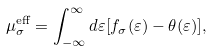<formula> <loc_0><loc_0><loc_500><loc_500>\mu ^ { \text {eff} } _ { \sigma } = \int _ { - \infty } ^ { \infty } d \varepsilon [ f _ { \sigma } ( \varepsilon ) - \theta ( \varepsilon ) ] ,</formula> 